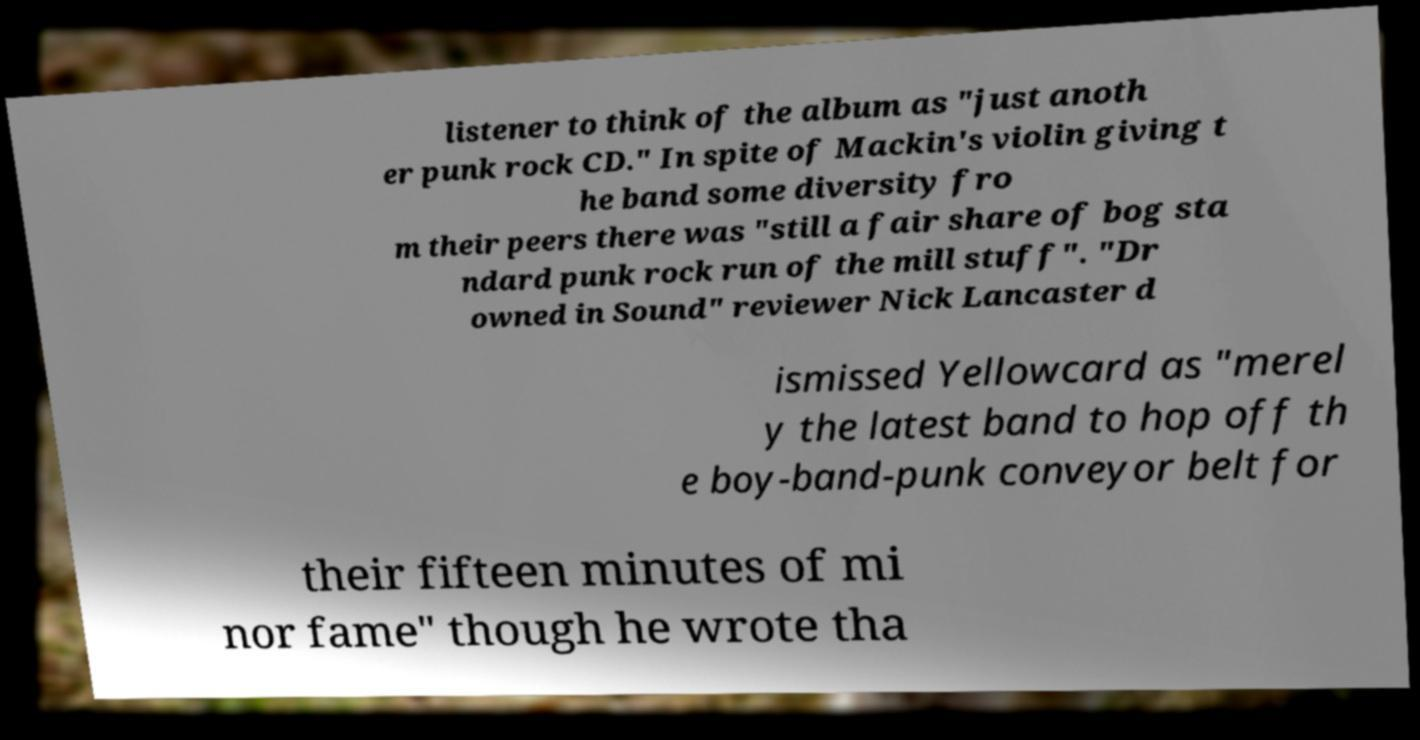What messages or text are displayed in this image? I need them in a readable, typed format. listener to think of the album as "just anoth er punk rock CD." In spite of Mackin's violin giving t he band some diversity fro m their peers there was "still a fair share of bog sta ndard punk rock run of the mill stuff". "Dr owned in Sound" reviewer Nick Lancaster d ismissed Yellowcard as "merel y the latest band to hop off th e boy-band-punk conveyor belt for their fifteen minutes of mi nor fame" though he wrote tha 